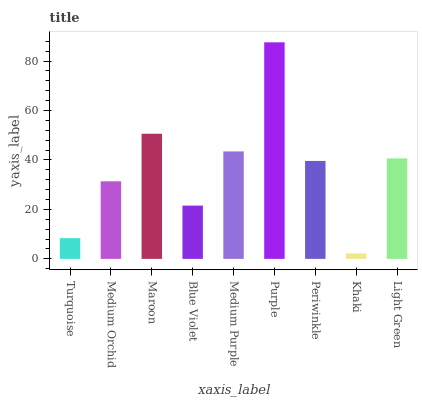Is Khaki the minimum?
Answer yes or no. Yes. Is Purple the maximum?
Answer yes or no. Yes. Is Medium Orchid the minimum?
Answer yes or no. No. Is Medium Orchid the maximum?
Answer yes or no. No. Is Medium Orchid greater than Turquoise?
Answer yes or no. Yes. Is Turquoise less than Medium Orchid?
Answer yes or no. Yes. Is Turquoise greater than Medium Orchid?
Answer yes or no. No. Is Medium Orchid less than Turquoise?
Answer yes or no. No. Is Periwinkle the high median?
Answer yes or no. Yes. Is Periwinkle the low median?
Answer yes or no. Yes. Is Medium Purple the high median?
Answer yes or no. No. Is Blue Violet the low median?
Answer yes or no. No. 